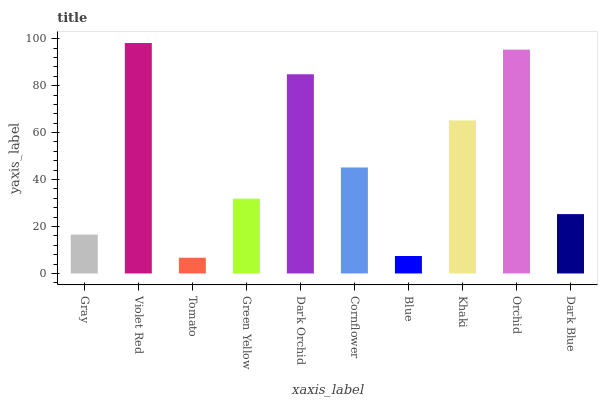Is Tomato the minimum?
Answer yes or no. Yes. Is Violet Red the maximum?
Answer yes or no. Yes. Is Violet Red the minimum?
Answer yes or no. No. Is Tomato the maximum?
Answer yes or no. No. Is Violet Red greater than Tomato?
Answer yes or no. Yes. Is Tomato less than Violet Red?
Answer yes or no. Yes. Is Tomato greater than Violet Red?
Answer yes or no. No. Is Violet Red less than Tomato?
Answer yes or no. No. Is Cornflower the high median?
Answer yes or no. Yes. Is Green Yellow the low median?
Answer yes or no. Yes. Is Dark Orchid the high median?
Answer yes or no. No. Is Khaki the low median?
Answer yes or no. No. 